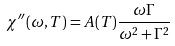Convert formula to latex. <formula><loc_0><loc_0><loc_500><loc_500>\chi ^ { \prime \prime } ( \omega , T ) = A ( T ) \frac { \omega \Gamma } { \omega ^ { 2 } + \Gamma ^ { 2 } }</formula> 